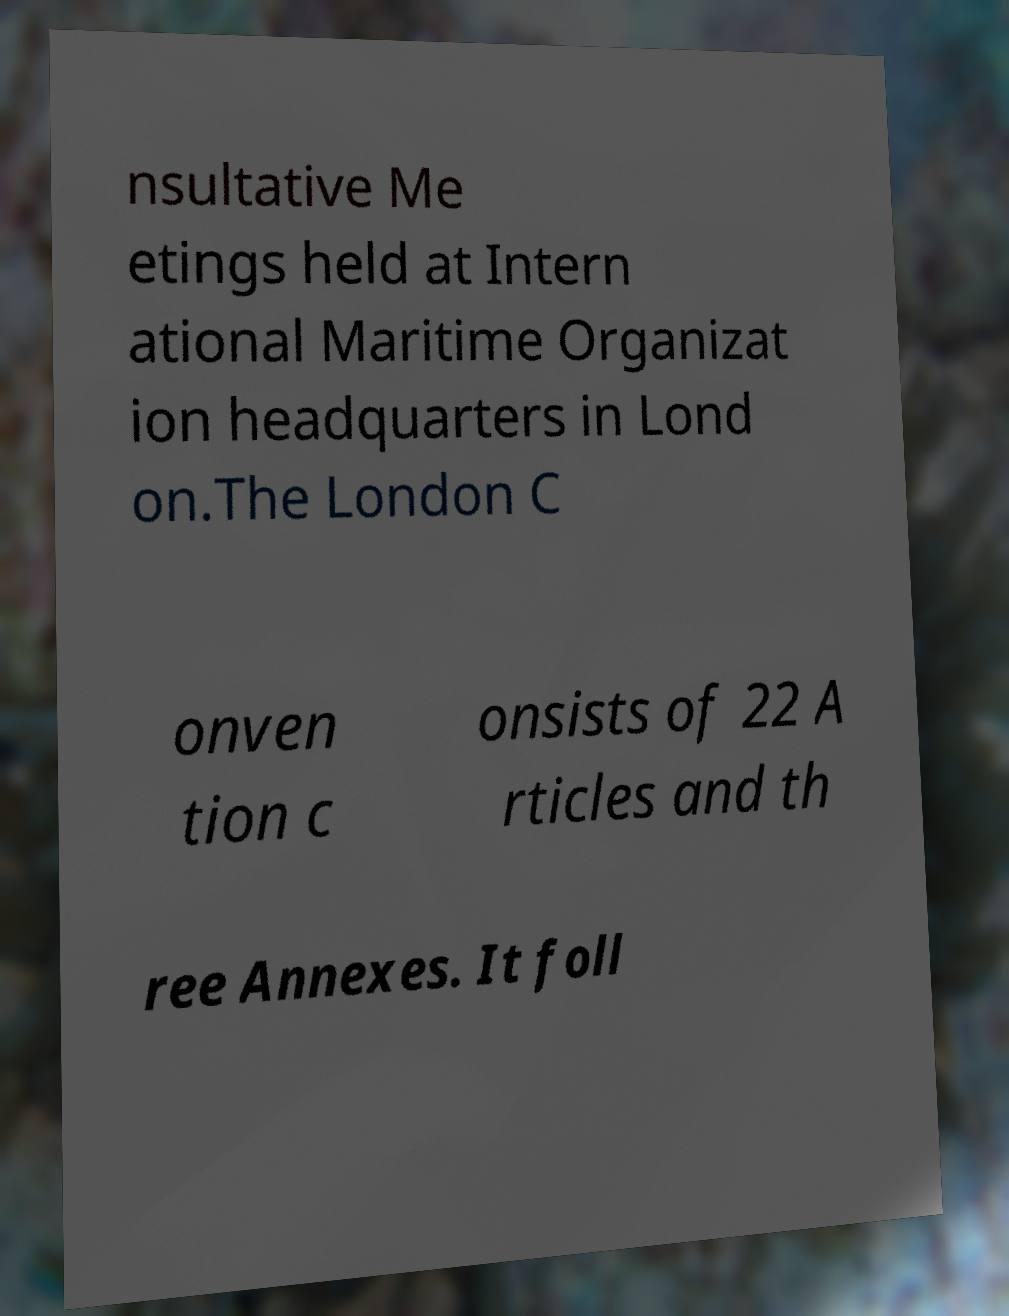Please identify and transcribe the text found in this image. nsultative Me etings held at Intern ational Maritime Organizat ion headquarters in Lond on.The London C onven tion c onsists of 22 A rticles and th ree Annexes. It foll 